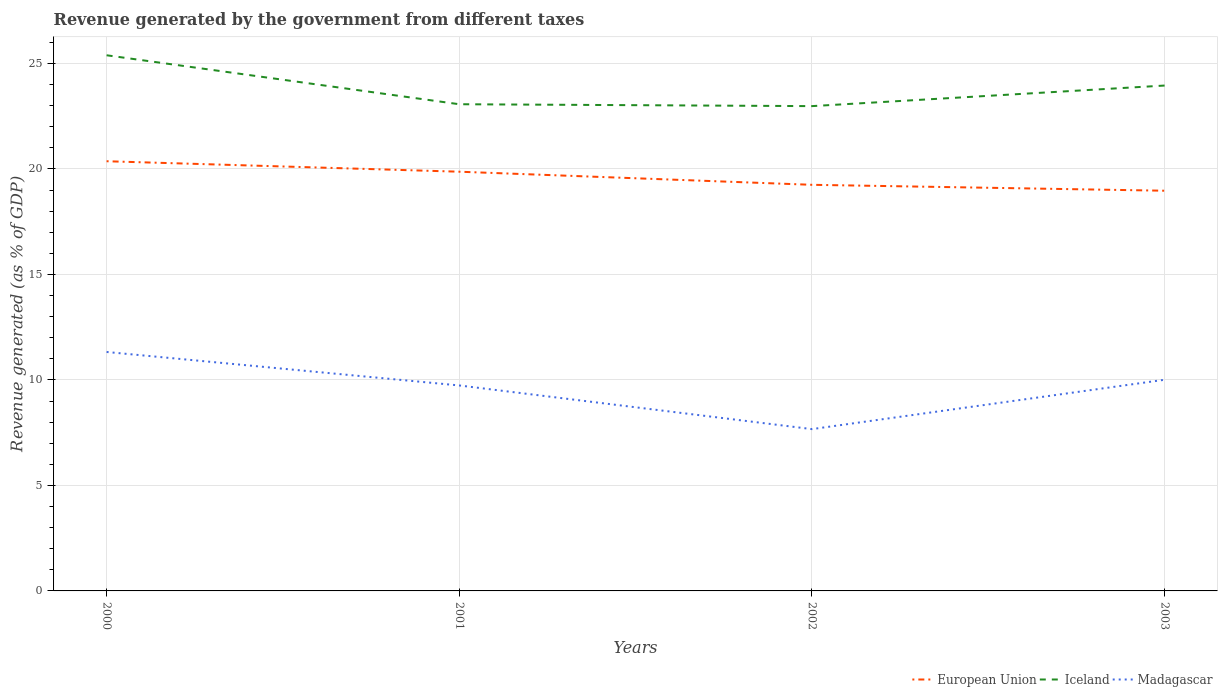How many different coloured lines are there?
Give a very brief answer. 3. Is the number of lines equal to the number of legend labels?
Your answer should be very brief. Yes. Across all years, what is the maximum revenue generated by the government in Iceland?
Offer a very short reply. 22.98. What is the total revenue generated by the government in European Union in the graph?
Provide a short and direct response. 0.5. What is the difference between the highest and the second highest revenue generated by the government in Iceland?
Your response must be concise. 2.41. What is the difference between the highest and the lowest revenue generated by the government in Iceland?
Offer a terse response. 2. Is the revenue generated by the government in Madagascar strictly greater than the revenue generated by the government in Iceland over the years?
Make the answer very short. Yes. How many years are there in the graph?
Your answer should be very brief. 4. What is the difference between two consecutive major ticks on the Y-axis?
Your answer should be compact. 5. Does the graph contain any zero values?
Offer a very short reply. No. Where does the legend appear in the graph?
Your answer should be compact. Bottom right. What is the title of the graph?
Give a very brief answer. Revenue generated by the government from different taxes. What is the label or title of the X-axis?
Give a very brief answer. Years. What is the label or title of the Y-axis?
Make the answer very short. Revenue generated (as % of GDP). What is the Revenue generated (as % of GDP) in European Union in 2000?
Provide a short and direct response. 20.37. What is the Revenue generated (as % of GDP) in Iceland in 2000?
Provide a succinct answer. 25.39. What is the Revenue generated (as % of GDP) in Madagascar in 2000?
Your response must be concise. 11.33. What is the Revenue generated (as % of GDP) of European Union in 2001?
Offer a very short reply. 19.87. What is the Revenue generated (as % of GDP) in Iceland in 2001?
Provide a succinct answer. 23.07. What is the Revenue generated (as % of GDP) in Madagascar in 2001?
Offer a terse response. 9.74. What is the Revenue generated (as % of GDP) in European Union in 2002?
Your answer should be very brief. 19.25. What is the Revenue generated (as % of GDP) in Iceland in 2002?
Your response must be concise. 22.98. What is the Revenue generated (as % of GDP) in Madagascar in 2002?
Ensure brevity in your answer.  7.67. What is the Revenue generated (as % of GDP) of European Union in 2003?
Offer a very short reply. 18.97. What is the Revenue generated (as % of GDP) of Iceland in 2003?
Ensure brevity in your answer.  23.95. What is the Revenue generated (as % of GDP) in Madagascar in 2003?
Offer a very short reply. 10.01. Across all years, what is the maximum Revenue generated (as % of GDP) in European Union?
Your response must be concise. 20.37. Across all years, what is the maximum Revenue generated (as % of GDP) in Iceland?
Provide a succinct answer. 25.39. Across all years, what is the maximum Revenue generated (as % of GDP) in Madagascar?
Make the answer very short. 11.33. Across all years, what is the minimum Revenue generated (as % of GDP) of European Union?
Provide a short and direct response. 18.97. Across all years, what is the minimum Revenue generated (as % of GDP) of Iceland?
Make the answer very short. 22.98. Across all years, what is the minimum Revenue generated (as % of GDP) in Madagascar?
Keep it short and to the point. 7.67. What is the total Revenue generated (as % of GDP) of European Union in the graph?
Offer a terse response. 78.46. What is the total Revenue generated (as % of GDP) in Iceland in the graph?
Your answer should be compact. 95.39. What is the total Revenue generated (as % of GDP) of Madagascar in the graph?
Give a very brief answer. 38.74. What is the difference between the Revenue generated (as % of GDP) in European Union in 2000 and that in 2001?
Make the answer very short. 0.5. What is the difference between the Revenue generated (as % of GDP) of Iceland in 2000 and that in 2001?
Make the answer very short. 2.32. What is the difference between the Revenue generated (as % of GDP) in Madagascar in 2000 and that in 2001?
Your answer should be compact. 1.59. What is the difference between the Revenue generated (as % of GDP) in European Union in 2000 and that in 2002?
Provide a short and direct response. 1.12. What is the difference between the Revenue generated (as % of GDP) in Iceland in 2000 and that in 2002?
Offer a terse response. 2.41. What is the difference between the Revenue generated (as % of GDP) in Madagascar in 2000 and that in 2002?
Provide a succinct answer. 3.66. What is the difference between the Revenue generated (as % of GDP) of European Union in 2000 and that in 2003?
Your answer should be very brief. 1.4. What is the difference between the Revenue generated (as % of GDP) in Iceland in 2000 and that in 2003?
Keep it short and to the point. 1.44. What is the difference between the Revenue generated (as % of GDP) of Madagascar in 2000 and that in 2003?
Provide a short and direct response. 1.32. What is the difference between the Revenue generated (as % of GDP) of European Union in 2001 and that in 2002?
Offer a terse response. 0.62. What is the difference between the Revenue generated (as % of GDP) in Iceland in 2001 and that in 2002?
Give a very brief answer. 0.09. What is the difference between the Revenue generated (as % of GDP) of Madagascar in 2001 and that in 2002?
Your answer should be compact. 2.07. What is the difference between the Revenue generated (as % of GDP) of European Union in 2001 and that in 2003?
Your answer should be very brief. 0.9. What is the difference between the Revenue generated (as % of GDP) of Iceland in 2001 and that in 2003?
Your response must be concise. -0.89. What is the difference between the Revenue generated (as % of GDP) in Madagascar in 2001 and that in 2003?
Offer a terse response. -0.27. What is the difference between the Revenue generated (as % of GDP) of European Union in 2002 and that in 2003?
Your answer should be compact. 0.28. What is the difference between the Revenue generated (as % of GDP) in Iceland in 2002 and that in 2003?
Your answer should be very brief. -0.98. What is the difference between the Revenue generated (as % of GDP) of Madagascar in 2002 and that in 2003?
Provide a succinct answer. -2.34. What is the difference between the Revenue generated (as % of GDP) in European Union in 2000 and the Revenue generated (as % of GDP) in Iceland in 2001?
Ensure brevity in your answer.  -2.7. What is the difference between the Revenue generated (as % of GDP) in European Union in 2000 and the Revenue generated (as % of GDP) in Madagascar in 2001?
Offer a terse response. 10.63. What is the difference between the Revenue generated (as % of GDP) of Iceland in 2000 and the Revenue generated (as % of GDP) of Madagascar in 2001?
Provide a succinct answer. 15.65. What is the difference between the Revenue generated (as % of GDP) of European Union in 2000 and the Revenue generated (as % of GDP) of Iceland in 2002?
Offer a very short reply. -2.61. What is the difference between the Revenue generated (as % of GDP) in European Union in 2000 and the Revenue generated (as % of GDP) in Madagascar in 2002?
Provide a short and direct response. 12.7. What is the difference between the Revenue generated (as % of GDP) in Iceland in 2000 and the Revenue generated (as % of GDP) in Madagascar in 2002?
Give a very brief answer. 17.72. What is the difference between the Revenue generated (as % of GDP) in European Union in 2000 and the Revenue generated (as % of GDP) in Iceland in 2003?
Make the answer very short. -3.59. What is the difference between the Revenue generated (as % of GDP) of European Union in 2000 and the Revenue generated (as % of GDP) of Madagascar in 2003?
Make the answer very short. 10.36. What is the difference between the Revenue generated (as % of GDP) in Iceland in 2000 and the Revenue generated (as % of GDP) in Madagascar in 2003?
Ensure brevity in your answer.  15.38. What is the difference between the Revenue generated (as % of GDP) of European Union in 2001 and the Revenue generated (as % of GDP) of Iceland in 2002?
Your answer should be very brief. -3.11. What is the difference between the Revenue generated (as % of GDP) in European Union in 2001 and the Revenue generated (as % of GDP) in Madagascar in 2002?
Provide a succinct answer. 12.2. What is the difference between the Revenue generated (as % of GDP) of Iceland in 2001 and the Revenue generated (as % of GDP) of Madagascar in 2002?
Make the answer very short. 15.4. What is the difference between the Revenue generated (as % of GDP) in European Union in 2001 and the Revenue generated (as % of GDP) in Iceland in 2003?
Your answer should be compact. -4.08. What is the difference between the Revenue generated (as % of GDP) of European Union in 2001 and the Revenue generated (as % of GDP) of Madagascar in 2003?
Provide a short and direct response. 9.86. What is the difference between the Revenue generated (as % of GDP) in Iceland in 2001 and the Revenue generated (as % of GDP) in Madagascar in 2003?
Provide a short and direct response. 13.06. What is the difference between the Revenue generated (as % of GDP) of European Union in 2002 and the Revenue generated (as % of GDP) of Iceland in 2003?
Offer a very short reply. -4.71. What is the difference between the Revenue generated (as % of GDP) of European Union in 2002 and the Revenue generated (as % of GDP) of Madagascar in 2003?
Ensure brevity in your answer.  9.24. What is the difference between the Revenue generated (as % of GDP) in Iceland in 2002 and the Revenue generated (as % of GDP) in Madagascar in 2003?
Give a very brief answer. 12.97. What is the average Revenue generated (as % of GDP) in European Union per year?
Your answer should be compact. 19.61. What is the average Revenue generated (as % of GDP) in Iceland per year?
Your answer should be very brief. 23.85. What is the average Revenue generated (as % of GDP) of Madagascar per year?
Offer a terse response. 9.69. In the year 2000, what is the difference between the Revenue generated (as % of GDP) of European Union and Revenue generated (as % of GDP) of Iceland?
Ensure brevity in your answer.  -5.02. In the year 2000, what is the difference between the Revenue generated (as % of GDP) of European Union and Revenue generated (as % of GDP) of Madagascar?
Give a very brief answer. 9.04. In the year 2000, what is the difference between the Revenue generated (as % of GDP) of Iceland and Revenue generated (as % of GDP) of Madagascar?
Offer a terse response. 14.06. In the year 2001, what is the difference between the Revenue generated (as % of GDP) of European Union and Revenue generated (as % of GDP) of Iceland?
Your answer should be compact. -3.2. In the year 2001, what is the difference between the Revenue generated (as % of GDP) of European Union and Revenue generated (as % of GDP) of Madagascar?
Provide a succinct answer. 10.13. In the year 2001, what is the difference between the Revenue generated (as % of GDP) in Iceland and Revenue generated (as % of GDP) in Madagascar?
Offer a terse response. 13.33. In the year 2002, what is the difference between the Revenue generated (as % of GDP) of European Union and Revenue generated (as % of GDP) of Iceland?
Provide a short and direct response. -3.73. In the year 2002, what is the difference between the Revenue generated (as % of GDP) in European Union and Revenue generated (as % of GDP) in Madagascar?
Your answer should be very brief. 11.58. In the year 2002, what is the difference between the Revenue generated (as % of GDP) in Iceland and Revenue generated (as % of GDP) in Madagascar?
Offer a very short reply. 15.31. In the year 2003, what is the difference between the Revenue generated (as % of GDP) of European Union and Revenue generated (as % of GDP) of Iceland?
Give a very brief answer. -4.99. In the year 2003, what is the difference between the Revenue generated (as % of GDP) in European Union and Revenue generated (as % of GDP) in Madagascar?
Give a very brief answer. 8.96. In the year 2003, what is the difference between the Revenue generated (as % of GDP) of Iceland and Revenue generated (as % of GDP) of Madagascar?
Your answer should be very brief. 13.95. What is the ratio of the Revenue generated (as % of GDP) in European Union in 2000 to that in 2001?
Ensure brevity in your answer.  1.02. What is the ratio of the Revenue generated (as % of GDP) of Iceland in 2000 to that in 2001?
Your answer should be compact. 1.1. What is the ratio of the Revenue generated (as % of GDP) in Madagascar in 2000 to that in 2001?
Offer a very short reply. 1.16. What is the ratio of the Revenue generated (as % of GDP) in European Union in 2000 to that in 2002?
Provide a succinct answer. 1.06. What is the ratio of the Revenue generated (as % of GDP) in Iceland in 2000 to that in 2002?
Ensure brevity in your answer.  1.1. What is the ratio of the Revenue generated (as % of GDP) in Madagascar in 2000 to that in 2002?
Provide a short and direct response. 1.48. What is the ratio of the Revenue generated (as % of GDP) of European Union in 2000 to that in 2003?
Your answer should be very brief. 1.07. What is the ratio of the Revenue generated (as % of GDP) of Iceland in 2000 to that in 2003?
Offer a terse response. 1.06. What is the ratio of the Revenue generated (as % of GDP) in Madagascar in 2000 to that in 2003?
Make the answer very short. 1.13. What is the ratio of the Revenue generated (as % of GDP) of European Union in 2001 to that in 2002?
Offer a terse response. 1.03. What is the ratio of the Revenue generated (as % of GDP) of Iceland in 2001 to that in 2002?
Make the answer very short. 1. What is the ratio of the Revenue generated (as % of GDP) of Madagascar in 2001 to that in 2002?
Ensure brevity in your answer.  1.27. What is the ratio of the Revenue generated (as % of GDP) in European Union in 2001 to that in 2003?
Offer a very short reply. 1.05. What is the ratio of the Revenue generated (as % of GDP) of Iceland in 2001 to that in 2003?
Provide a short and direct response. 0.96. What is the ratio of the Revenue generated (as % of GDP) in European Union in 2002 to that in 2003?
Ensure brevity in your answer.  1.01. What is the ratio of the Revenue generated (as % of GDP) of Iceland in 2002 to that in 2003?
Provide a succinct answer. 0.96. What is the ratio of the Revenue generated (as % of GDP) of Madagascar in 2002 to that in 2003?
Give a very brief answer. 0.77. What is the difference between the highest and the second highest Revenue generated (as % of GDP) in European Union?
Your response must be concise. 0.5. What is the difference between the highest and the second highest Revenue generated (as % of GDP) of Iceland?
Ensure brevity in your answer.  1.44. What is the difference between the highest and the second highest Revenue generated (as % of GDP) of Madagascar?
Keep it short and to the point. 1.32. What is the difference between the highest and the lowest Revenue generated (as % of GDP) in European Union?
Provide a succinct answer. 1.4. What is the difference between the highest and the lowest Revenue generated (as % of GDP) of Iceland?
Ensure brevity in your answer.  2.41. What is the difference between the highest and the lowest Revenue generated (as % of GDP) of Madagascar?
Your answer should be compact. 3.66. 